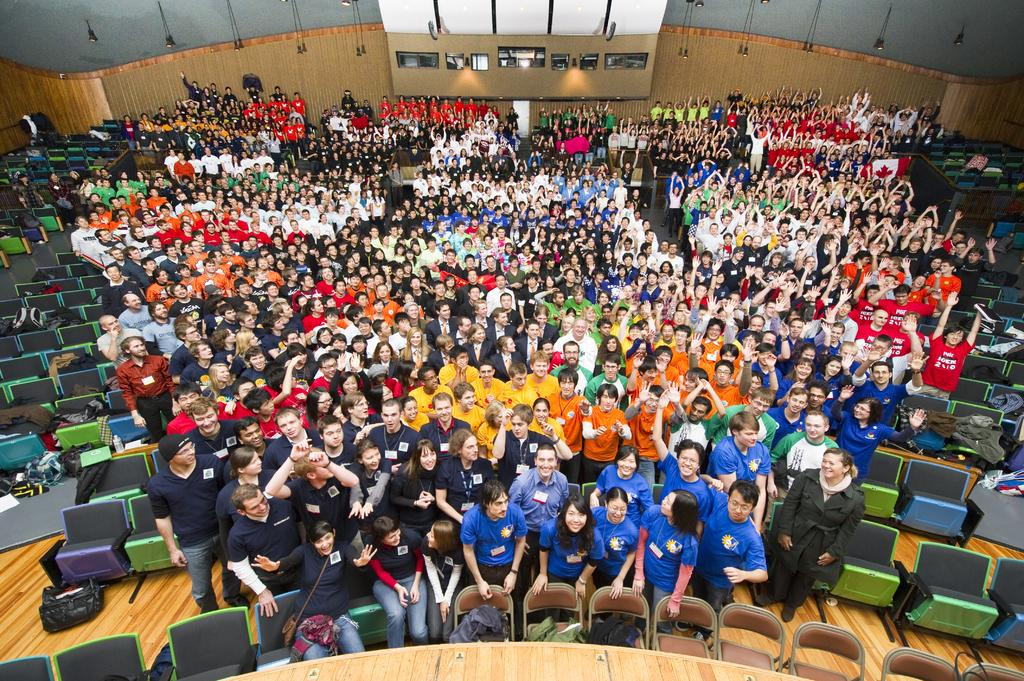Who or what is present in the image? There are people in the image. What objects are visible in the image that the people might use? There are chairs in the image that the people might use. What can be seen in the background of the image? There is a wall and lights in the background of the image. What type of flooring is visible at the bottom of the image? There is wooden flooring at the bottom of the image. What type of eggnog is being served on the wooden flooring in the image? There is no eggnog present in the image; it only features people, chairs, a wall, lights, and wooden flooring. 